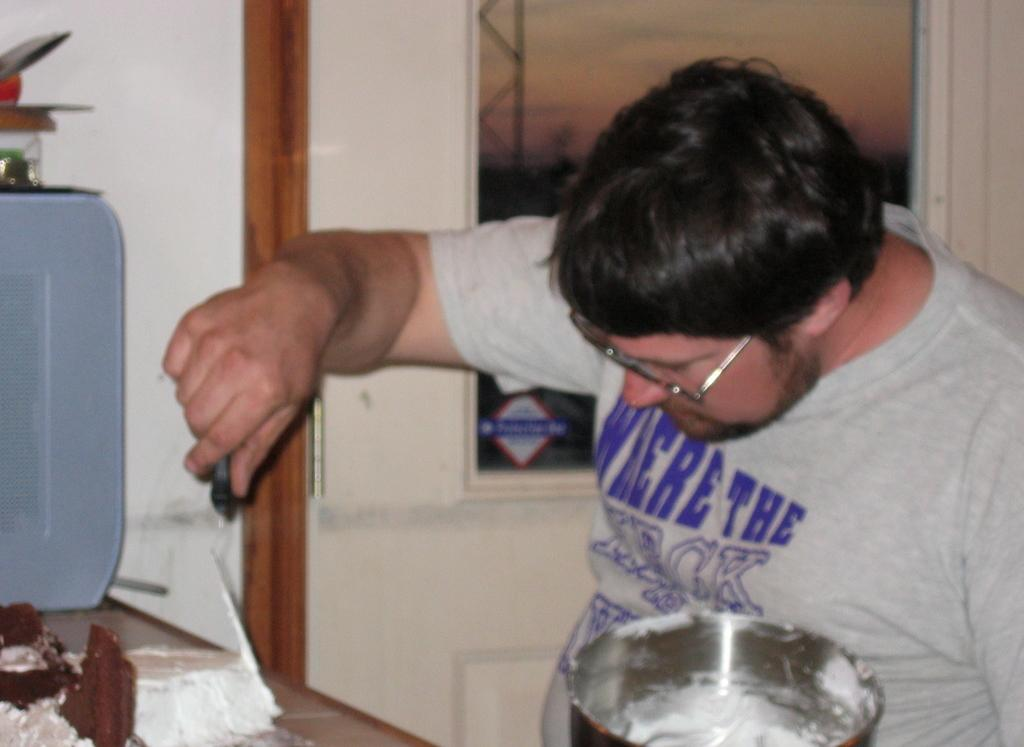<image>
Provide a brief description of the given image. A man sitting at a desk with a shirt that read where the heck. 